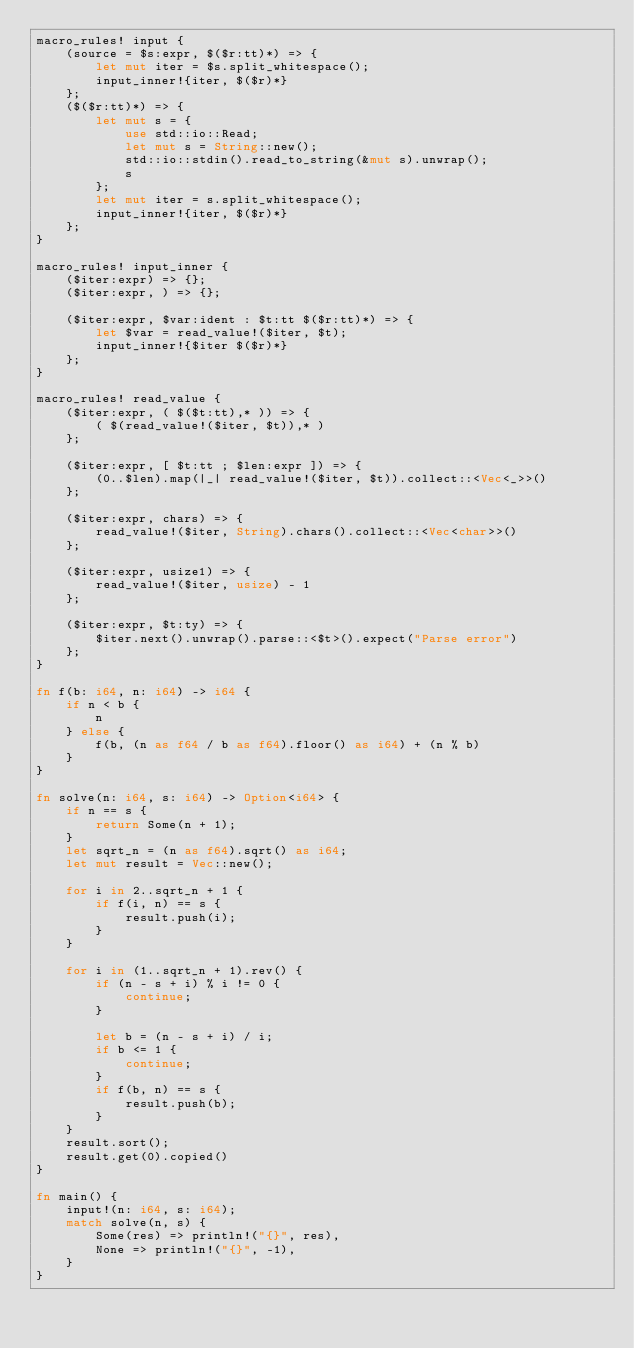Convert code to text. <code><loc_0><loc_0><loc_500><loc_500><_Rust_>macro_rules! input {
    (source = $s:expr, $($r:tt)*) => {
        let mut iter = $s.split_whitespace();
        input_inner!{iter, $($r)*}
    };
    ($($r:tt)*) => {
        let mut s = {
            use std::io::Read;
            let mut s = String::new();
            std::io::stdin().read_to_string(&mut s).unwrap();
            s
        };
        let mut iter = s.split_whitespace();
        input_inner!{iter, $($r)*}
    };
}

macro_rules! input_inner {
    ($iter:expr) => {};
    ($iter:expr, ) => {};

    ($iter:expr, $var:ident : $t:tt $($r:tt)*) => {
        let $var = read_value!($iter, $t);
        input_inner!{$iter $($r)*}
    };
}

macro_rules! read_value {
    ($iter:expr, ( $($t:tt),* )) => {
        ( $(read_value!($iter, $t)),* )
    };

    ($iter:expr, [ $t:tt ; $len:expr ]) => {
        (0..$len).map(|_| read_value!($iter, $t)).collect::<Vec<_>>()
    };

    ($iter:expr, chars) => {
        read_value!($iter, String).chars().collect::<Vec<char>>()
    };

    ($iter:expr, usize1) => {
        read_value!($iter, usize) - 1
    };

    ($iter:expr, $t:ty) => {
        $iter.next().unwrap().parse::<$t>().expect("Parse error")
    };
}

fn f(b: i64, n: i64) -> i64 {
    if n < b {
        n
    } else {
        f(b, (n as f64 / b as f64).floor() as i64) + (n % b)
    }
}

fn solve(n: i64, s: i64) -> Option<i64> {
    if n == s {
        return Some(n + 1);
    }
    let sqrt_n = (n as f64).sqrt() as i64;
    let mut result = Vec::new();

    for i in 2..sqrt_n + 1 {
        if f(i, n) == s {
            result.push(i);
        }
    }

    for i in (1..sqrt_n + 1).rev() {
        if (n - s + i) % i != 0 {
            continue;
        }

        let b = (n - s + i) / i;
        if b <= 1 {
            continue;
        }
        if f(b, n) == s {
            result.push(b);
        }
    }
    result.sort();
    result.get(0).copied()
}

fn main() {
    input!(n: i64, s: i64);
    match solve(n, s) {
        Some(res) => println!("{}", res),
        None => println!("{}", -1),
    }
}
</code> 